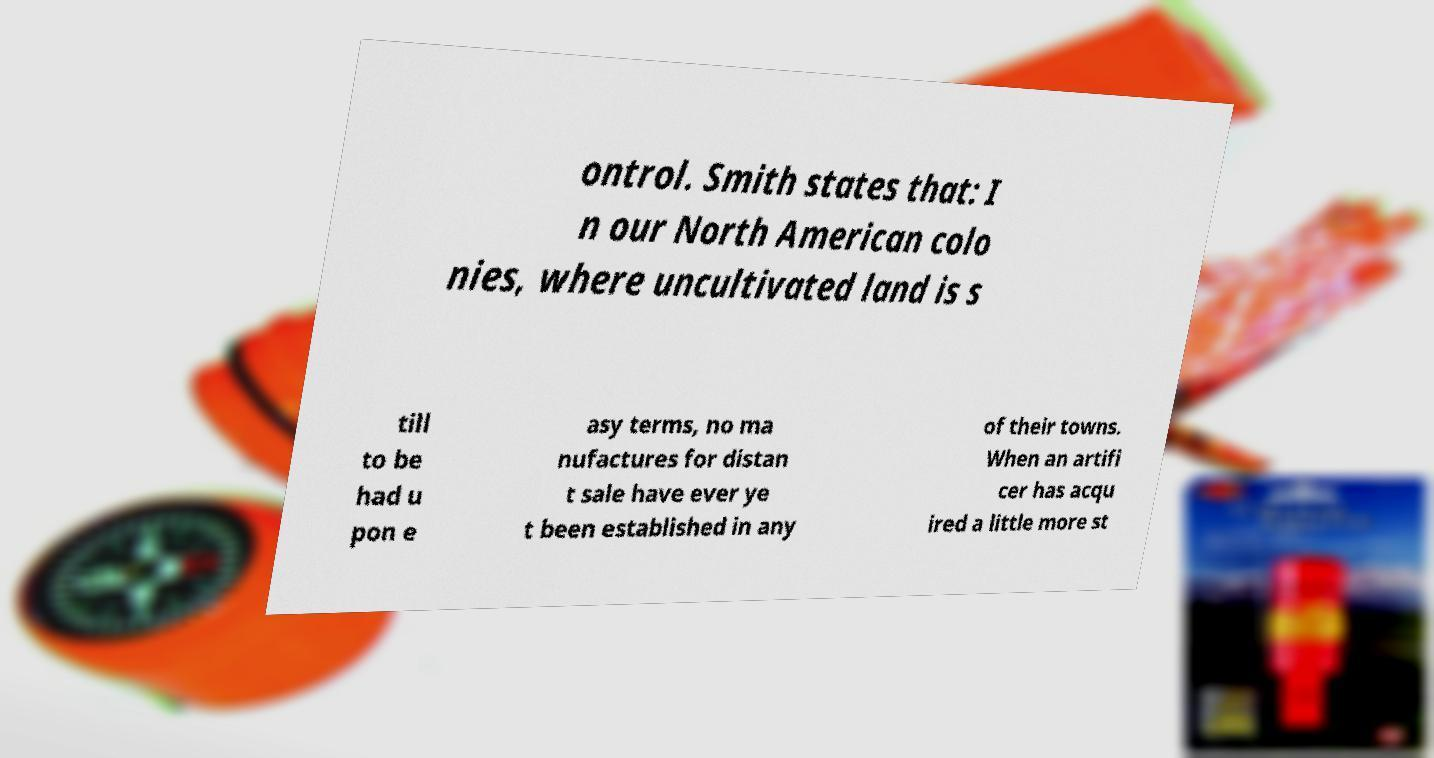For documentation purposes, I need the text within this image transcribed. Could you provide that? ontrol. Smith states that: I n our North American colo nies, where uncultivated land is s till to be had u pon e asy terms, no ma nufactures for distan t sale have ever ye t been established in any of their towns. When an artifi cer has acqu ired a little more st 